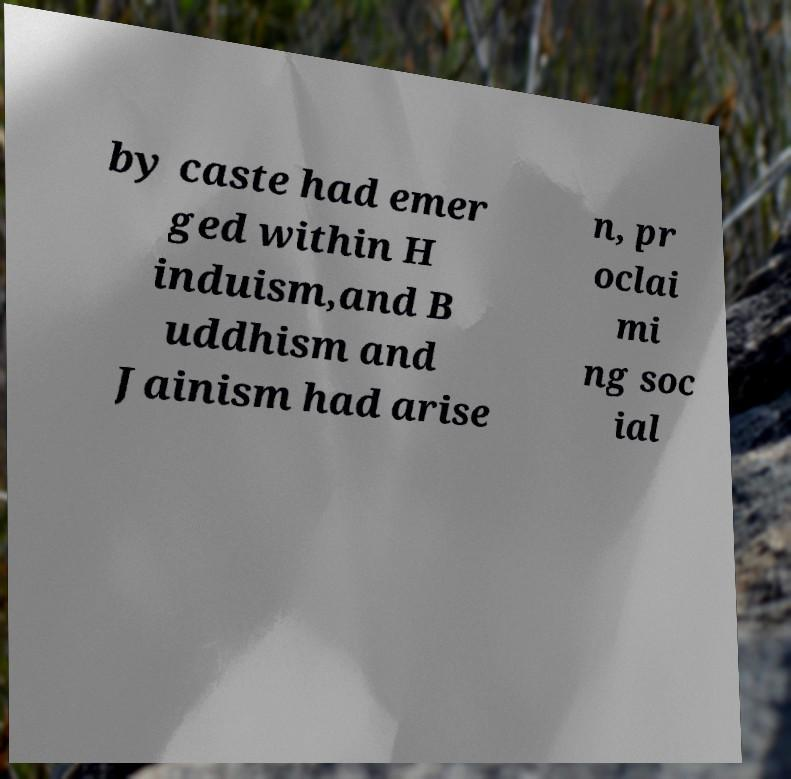Could you extract and type out the text from this image? by caste had emer ged within H induism,and B uddhism and Jainism had arise n, pr oclai mi ng soc ial 